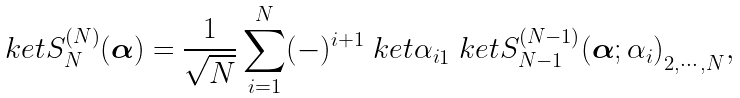Convert formula to latex. <formula><loc_0><loc_0><loc_500><loc_500>\ k e t { S ^ { ( N ) } _ { N } ( { \boldsymbol \alpha } ) } = \frac { 1 } { \sqrt { N } } \sum _ { i = 1 } ^ { N } ( - ) ^ { i + 1 } \ k e t { \alpha _ { i } } _ { 1 } \ k e t { S ^ { ( N - 1 ) } _ { N - 1 } ( { \boldsymbol \alpha } ; \alpha _ { i } ) } _ { 2 , \cdots , N } ,</formula> 